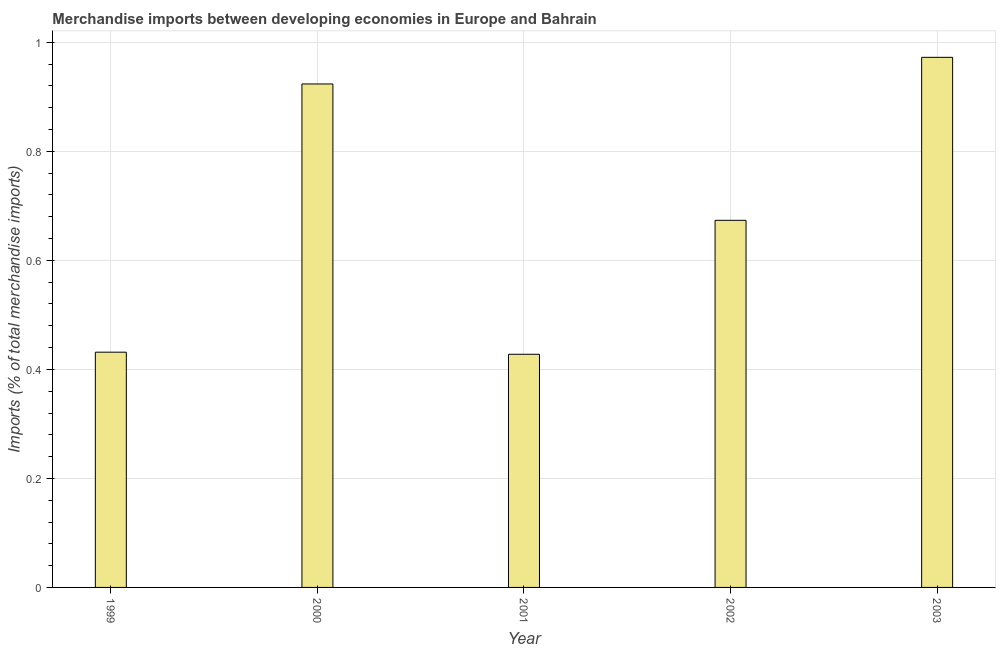Does the graph contain grids?
Offer a terse response. Yes. What is the title of the graph?
Your answer should be very brief. Merchandise imports between developing economies in Europe and Bahrain. What is the label or title of the Y-axis?
Make the answer very short. Imports (% of total merchandise imports). What is the merchandise imports in 2000?
Offer a very short reply. 0.92. Across all years, what is the maximum merchandise imports?
Provide a succinct answer. 0.97. Across all years, what is the minimum merchandise imports?
Give a very brief answer. 0.43. In which year was the merchandise imports maximum?
Provide a short and direct response. 2003. What is the sum of the merchandise imports?
Give a very brief answer. 3.43. What is the difference between the merchandise imports in 1999 and 2002?
Your answer should be compact. -0.24. What is the average merchandise imports per year?
Your answer should be compact. 0.69. What is the median merchandise imports?
Ensure brevity in your answer.  0.67. In how many years, is the merchandise imports greater than 0.76 %?
Your response must be concise. 2. What is the ratio of the merchandise imports in 2001 to that in 2002?
Offer a terse response. 0.64. Is the difference between the merchandise imports in 1999 and 2000 greater than the difference between any two years?
Provide a short and direct response. No. What is the difference between the highest and the second highest merchandise imports?
Your response must be concise. 0.05. What is the difference between the highest and the lowest merchandise imports?
Your response must be concise. 0.54. In how many years, is the merchandise imports greater than the average merchandise imports taken over all years?
Offer a terse response. 2. How many bars are there?
Provide a short and direct response. 5. How many years are there in the graph?
Ensure brevity in your answer.  5. What is the difference between two consecutive major ticks on the Y-axis?
Make the answer very short. 0.2. Are the values on the major ticks of Y-axis written in scientific E-notation?
Your answer should be very brief. No. What is the Imports (% of total merchandise imports) in 1999?
Your answer should be compact. 0.43. What is the Imports (% of total merchandise imports) of 2000?
Offer a very short reply. 0.92. What is the Imports (% of total merchandise imports) of 2001?
Make the answer very short. 0.43. What is the Imports (% of total merchandise imports) of 2002?
Offer a very short reply. 0.67. What is the Imports (% of total merchandise imports) of 2003?
Offer a very short reply. 0.97. What is the difference between the Imports (% of total merchandise imports) in 1999 and 2000?
Give a very brief answer. -0.49. What is the difference between the Imports (% of total merchandise imports) in 1999 and 2001?
Provide a succinct answer. 0. What is the difference between the Imports (% of total merchandise imports) in 1999 and 2002?
Offer a very short reply. -0.24. What is the difference between the Imports (% of total merchandise imports) in 1999 and 2003?
Make the answer very short. -0.54. What is the difference between the Imports (% of total merchandise imports) in 2000 and 2001?
Make the answer very short. 0.5. What is the difference between the Imports (% of total merchandise imports) in 2000 and 2002?
Your answer should be very brief. 0.25. What is the difference between the Imports (% of total merchandise imports) in 2000 and 2003?
Offer a very short reply. -0.05. What is the difference between the Imports (% of total merchandise imports) in 2001 and 2002?
Give a very brief answer. -0.25. What is the difference between the Imports (% of total merchandise imports) in 2001 and 2003?
Ensure brevity in your answer.  -0.54. What is the difference between the Imports (% of total merchandise imports) in 2002 and 2003?
Your answer should be very brief. -0.3. What is the ratio of the Imports (% of total merchandise imports) in 1999 to that in 2000?
Offer a terse response. 0.47. What is the ratio of the Imports (% of total merchandise imports) in 1999 to that in 2002?
Keep it short and to the point. 0.64. What is the ratio of the Imports (% of total merchandise imports) in 1999 to that in 2003?
Make the answer very short. 0.44. What is the ratio of the Imports (% of total merchandise imports) in 2000 to that in 2001?
Give a very brief answer. 2.16. What is the ratio of the Imports (% of total merchandise imports) in 2000 to that in 2002?
Give a very brief answer. 1.37. What is the ratio of the Imports (% of total merchandise imports) in 2001 to that in 2002?
Your answer should be very brief. 0.64. What is the ratio of the Imports (% of total merchandise imports) in 2001 to that in 2003?
Your answer should be compact. 0.44. What is the ratio of the Imports (% of total merchandise imports) in 2002 to that in 2003?
Keep it short and to the point. 0.69. 